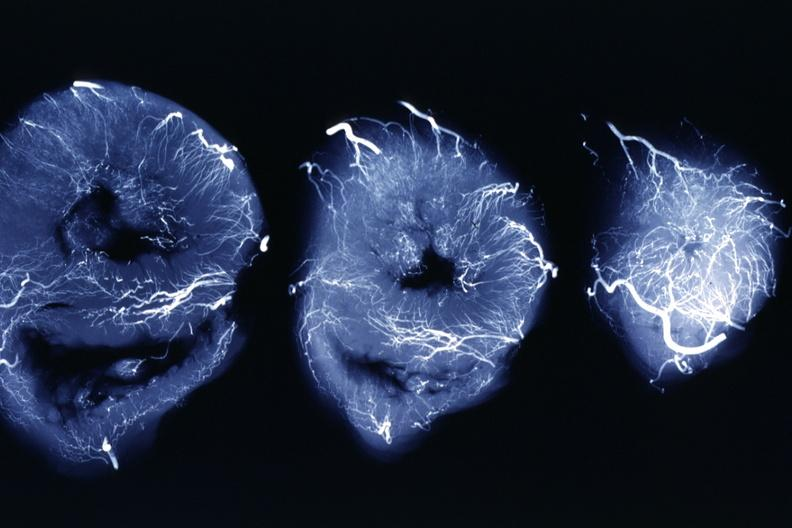what does this image show?
Answer the question using a single word or phrase. X-ray three horizontal slices of ventricles showing quite well the penetrating arteries 